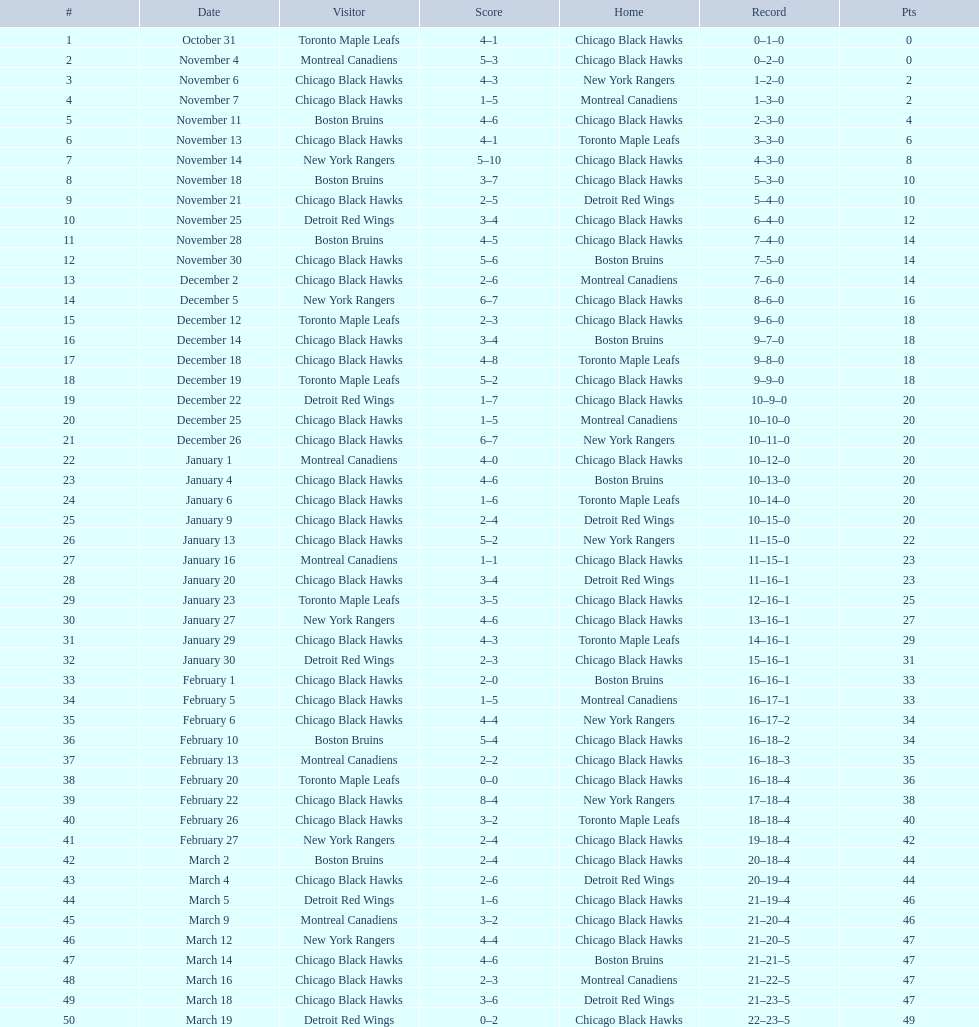On december 14 was the home team the chicago black hawks or the boston bruins? Boston Bruins. 